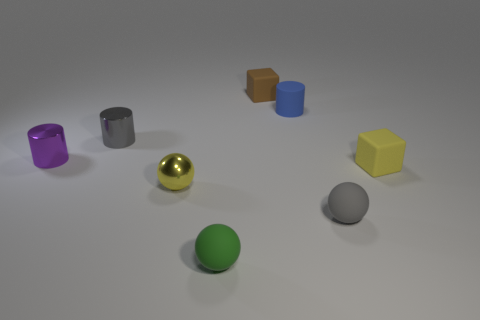There is a purple metallic cylinder behind the tiny gray object that is in front of the yellow matte object; what number of blocks are in front of it?
Ensure brevity in your answer.  1. There is a yellow object that is to the right of the green matte sphere; is it the same size as the cylinder to the right of the green thing?
Your answer should be compact. Yes. There is a tiny yellow object that is the same shape as the green matte thing; what material is it?
Provide a succinct answer. Metal. What number of big things are yellow balls or cyan things?
Make the answer very short. 0. What material is the small gray ball?
Your answer should be compact. Rubber. There is a object that is on the right side of the small blue rubber cylinder and behind the gray sphere; what is its material?
Offer a very short reply. Rubber. There is a rubber cylinder; is it the same color as the thing left of the gray cylinder?
Give a very brief answer. No. What material is the brown cube that is the same size as the green object?
Your answer should be compact. Rubber. Are there any tiny brown blocks made of the same material as the green ball?
Give a very brief answer. Yes. How many small gray objects are there?
Your answer should be very brief. 2. 